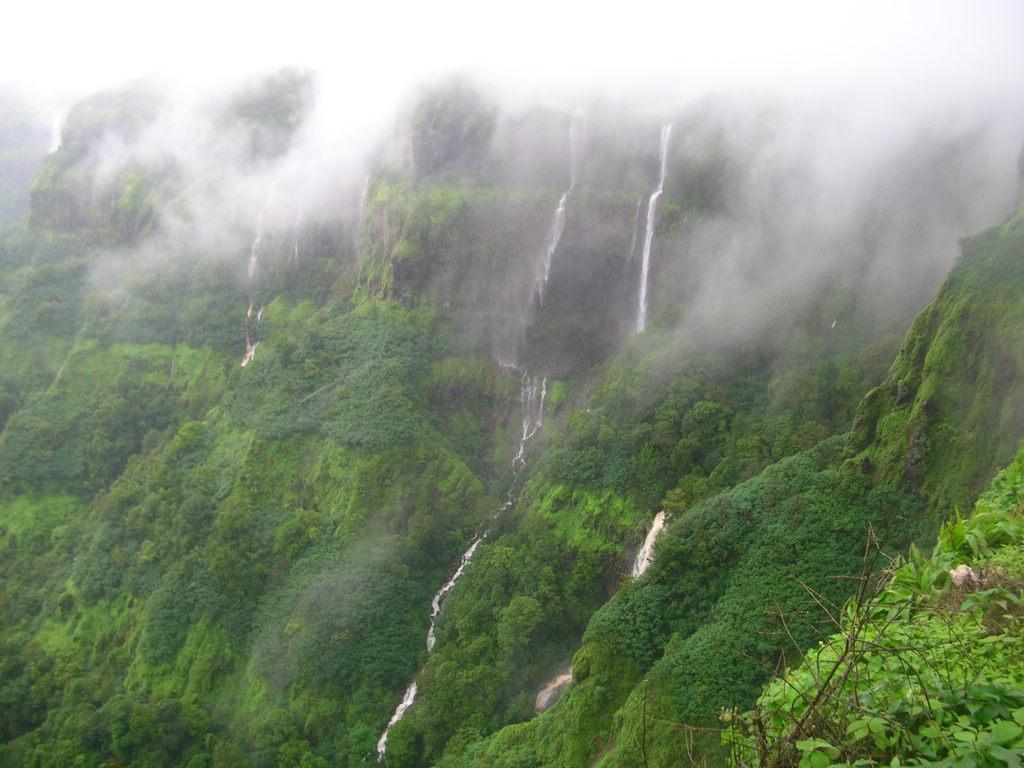What type of natural landform can be seen in the image? There are mountains in the image. What vegetation is present on the mountains? Trees are present on the mountains. What else can be seen in the image besides the mountains? There is water visible in the image. What atmospheric condition is present at the top of the image? There is fog at the top of the image. What time of day is depicted in the image? The time of day cannot be determined from the image, as there are no specific indicators of time. 